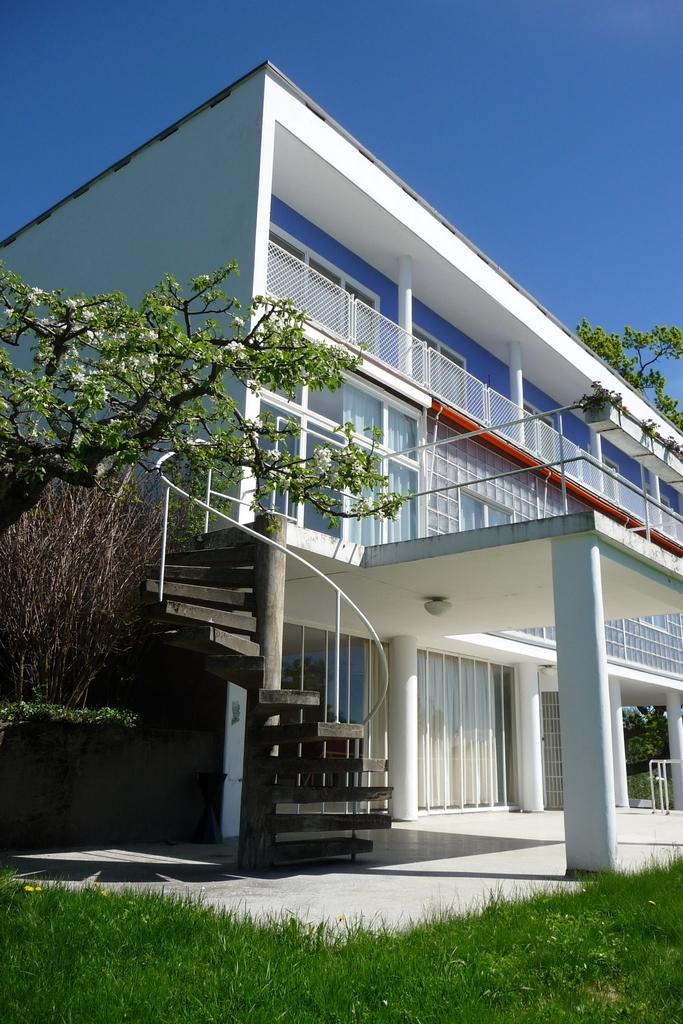What type of structure is visible in the image? There is a building in the image. What architectural feature can be seen in the image? There are there stairs in the image. What type of vegetation is present in the image? There are trees and grass in the image. What is the color of the sky in the image? The sky is blue at the top of the image. Can you see a boot lying on the grass in the image? There is no boot present in the image; it only features a building, stairs, trees, grass, and a blue sky. 